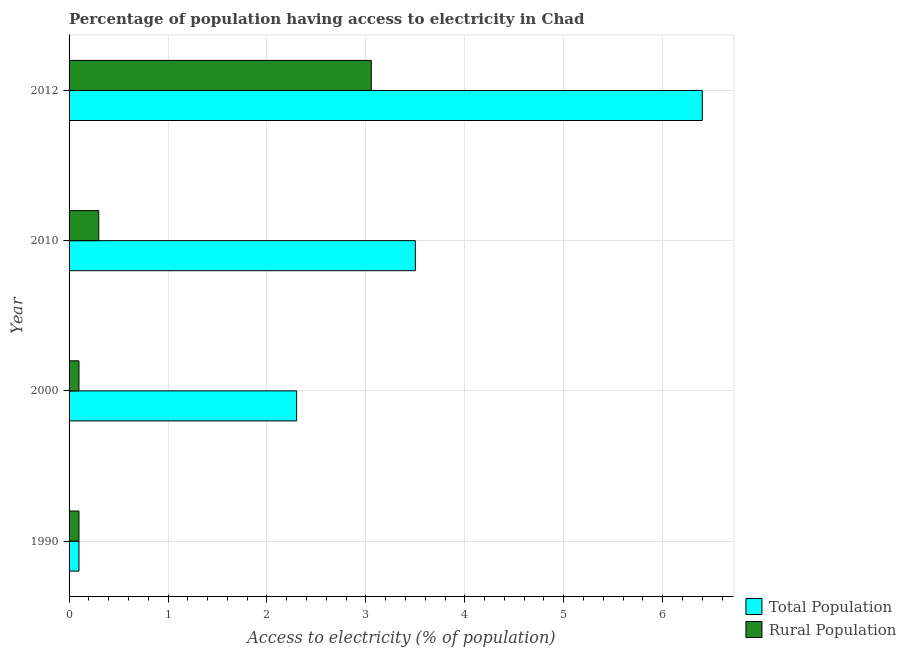How many different coloured bars are there?
Make the answer very short. 2. Are the number of bars per tick equal to the number of legend labels?
Your answer should be very brief. Yes. What is the percentage of rural population having access to electricity in 2012?
Offer a terse response. 3.05. In which year was the percentage of population having access to electricity maximum?
Offer a terse response. 2012. In which year was the percentage of population having access to electricity minimum?
Provide a succinct answer. 1990. What is the total percentage of rural population having access to electricity in the graph?
Keep it short and to the point. 3.55. What is the difference between the percentage of rural population having access to electricity in 2000 and that in 2012?
Offer a terse response. -2.96. What is the difference between the percentage of rural population having access to electricity in 2000 and the percentage of population having access to electricity in 2012?
Offer a terse response. -6.3. What is the average percentage of rural population having access to electricity per year?
Give a very brief answer. 0.89. In the year 2012, what is the difference between the percentage of population having access to electricity and percentage of rural population having access to electricity?
Offer a very short reply. 3.35. In how many years, is the percentage of population having access to electricity greater than 3.4 %?
Make the answer very short. 2. What is the ratio of the percentage of population having access to electricity in 1990 to that in 2012?
Provide a succinct answer. 0.02. Is the percentage of rural population having access to electricity in 2010 less than that in 2012?
Your answer should be very brief. Yes. What is the difference between the highest and the second highest percentage of rural population having access to electricity?
Provide a succinct answer. 2.75. What is the difference between the highest and the lowest percentage of population having access to electricity?
Give a very brief answer. 6.3. In how many years, is the percentage of rural population having access to electricity greater than the average percentage of rural population having access to electricity taken over all years?
Give a very brief answer. 1. Is the sum of the percentage of rural population having access to electricity in 1990 and 2010 greater than the maximum percentage of population having access to electricity across all years?
Give a very brief answer. No. What does the 1st bar from the top in 1990 represents?
Your answer should be compact. Rural Population. What does the 1st bar from the bottom in 2012 represents?
Make the answer very short. Total Population. How many bars are there?
Keep it short and to the point. 8. Are all the bars in the graph horizontal?
Your response must be concise. Yes. What is the difference between two consecutive major ticks on the X-axis?
Give a very brief answer. 1. Are the values on the major ticks of X-axis written in scientific E-notation?
Provide a succinct answer. No. Does the graph contain any zero values?
Ensure brevity in your answer.  No. Does the graph contain grids?
Offer a terse response. Yes. How many legend labels are there?
Ensure brevity in your answer.  2. How are the legend labels stacked?
Offer a terse response. Vertical. What is the title of the graph?
Give a very brief answer. Percentage of population having access to electricity in Chad. Does "Crop" appear as one of the legend labels in the graph?
Offer a very short reply. No. What is the label or title of the X-axis?
Keep it short and to the point. Access to electricity (% of population). What is the Access to electricity (% of population) of Rural Population in 2012?
Give a very brief answer. 3.05. Across all years, what is the maximum Access to electricity (% of population) of Total Population?
Give a very brief answer. 6.4. Across all years, what is the maximum Access to electricity (% of population) in Rural Population?
Give a very brief answer. 3.05. What is the total Access to electricity (% of population) of Total Population in the graph?
Make the answer very short. 12.3. What is the total Access to electricity (% of population) of Rural Population in the graph?
Make the answer very short. 3.55. What is the difference between the Access to electricity (% of population) in Rural Population in 1990 and that in 2000?
Ensure brevity in your answer.  0. What is the difference between the Access to electricity (% of population) in Rural Population in 1990 and that in 2010?
Keep it short and to the point. -0.2. What is the difference between the Access to electricity (% of population) in Rural Population in 1990 and that in 2012?
Your response must be concise. -2.95. What is the difference between the Access to electricity (% of population) of Rural Population in 2000 and that in 2012?
Your answer should be very brief. -2.95. What is the difference between the Access to electricity (% of population) of Total Population in 2010 and that in 2012?
Provide a short and direct response. -2.9. What is the difference between the Access to electricity (% of population) in Rural Population in 2010 and that in 2012?
Provide a succinct answer. -2.75. What is the difference between the Access to electricity (% of population) in Total Population in 1990 and the Access to electricity (% of population) in Rural Population in 2000?
Your answer should be compact. 0. What is the difference between the Access to electricity (% of population) in Total Population in 1990 and the Access to electricity (% of population) in Rural Population in 2010?
Provide a short and direct response. -0.2. What is the difference between the Access to electricity (% of population) in Total Population in 1990 and the Access to electricity (% of population) in Rural Population in 2012?
Provide a short and direct response. -2.95. What is the difference between the Access to electricity (% of population) in Total Population in 2000 and the Access to electricity (% of population) in Rural Population in 2012?
Ensure brevity in your answer.  -0.75. What is the difference between the Access to electricity (% of population) in Total Population in 2010 and the Access to electricity (% of population) in Rural Population in 2012?
Provide a succinct answer. 0.45. What is the average Access to electricity (% of population) in Total Population per year?
Your answer should be very brief. 3.08. What is the average Access to electricity (% of population) of Rural Population per year?
Offer a terse response. 0.89. In the year 2000, what is the difference between the Access to electricity (% of population) of Total Population and Access to electricity (% of population) of Rural Population?
Offer a terse response. 2.2. In the year 2012, what is the difference between the Access to electricity (% of population) in Total Population and Access to electricity (% of population) in Rural Population?
Give a very brief answer. 3.35. What is the ratio of the Access to electricity (% of population) in Total Population in 1990 to that in 2000?
Offer a very short reply. 0.04. What is the ratio of the Access to electricity (% of population) of Rural Population in 1990 to that in 2000?
Make the answer very short. 1. What is the ratio of the Access to electricity (% of population) in Total Population in 1990 to that in 2010?
Your answer should be very brief. 0.03. What is the ratio of the Access to electricity (% of population) in Rural Population in 1990 to that in 2010?
Offer a terse response. 0.33. What is the ratio of the Access to electricity (% of population) of Total Population in 1990 to that in 2012?
Provide a succinct answer. 0.02. What is the ratio of the Access to electricity (% of population) of Rural Population in 1990 to that in 2012?
Your answer should be compact. 0.03. What is the ratio of the Access to electricity (% of population) of Total Population in 2000 to that in 2010?
Make the answer very short. 0.66. What is the ratio of the Access to electricity (% of population) in Total Population in 2000 to that in 2012?
Provide a short and direct response. 0.36. What is the ratio of the Access to electricity (% of population) in Rural Population in 2000 to that in 2012?
Your answer should be compact. 0.03. What is the ratio of the Access to electricity (% of population) in Total Population in 2010 to that in 2012?
Your answer should be very brief. 0.55. What is the ratio of the Access to electricity (% of population) of Rural Population in 2010 to that in 2012?
Ensure brevity in your answer.  0.1. What is the difference between the highest and the second highest Access to electricity (% of population) in Total Population?
Provide a succinct answer. 2.9. What is the difference between the highest and the second highest Access to electricity (% of population) in Rural Population?
Offer a terse response. 2.75. What is the difference between the highest and the lowest Access to electricity (% of population) of Rural Population?
Your answer should be very brief. 2.95. 